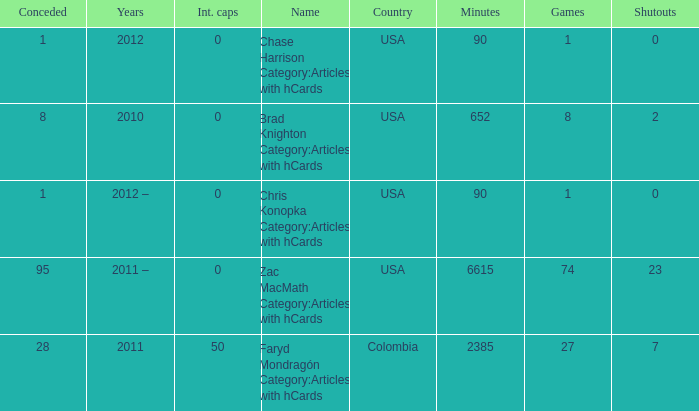When chase harrison category:articles with hcards is the name what is the year? 2012.0. 